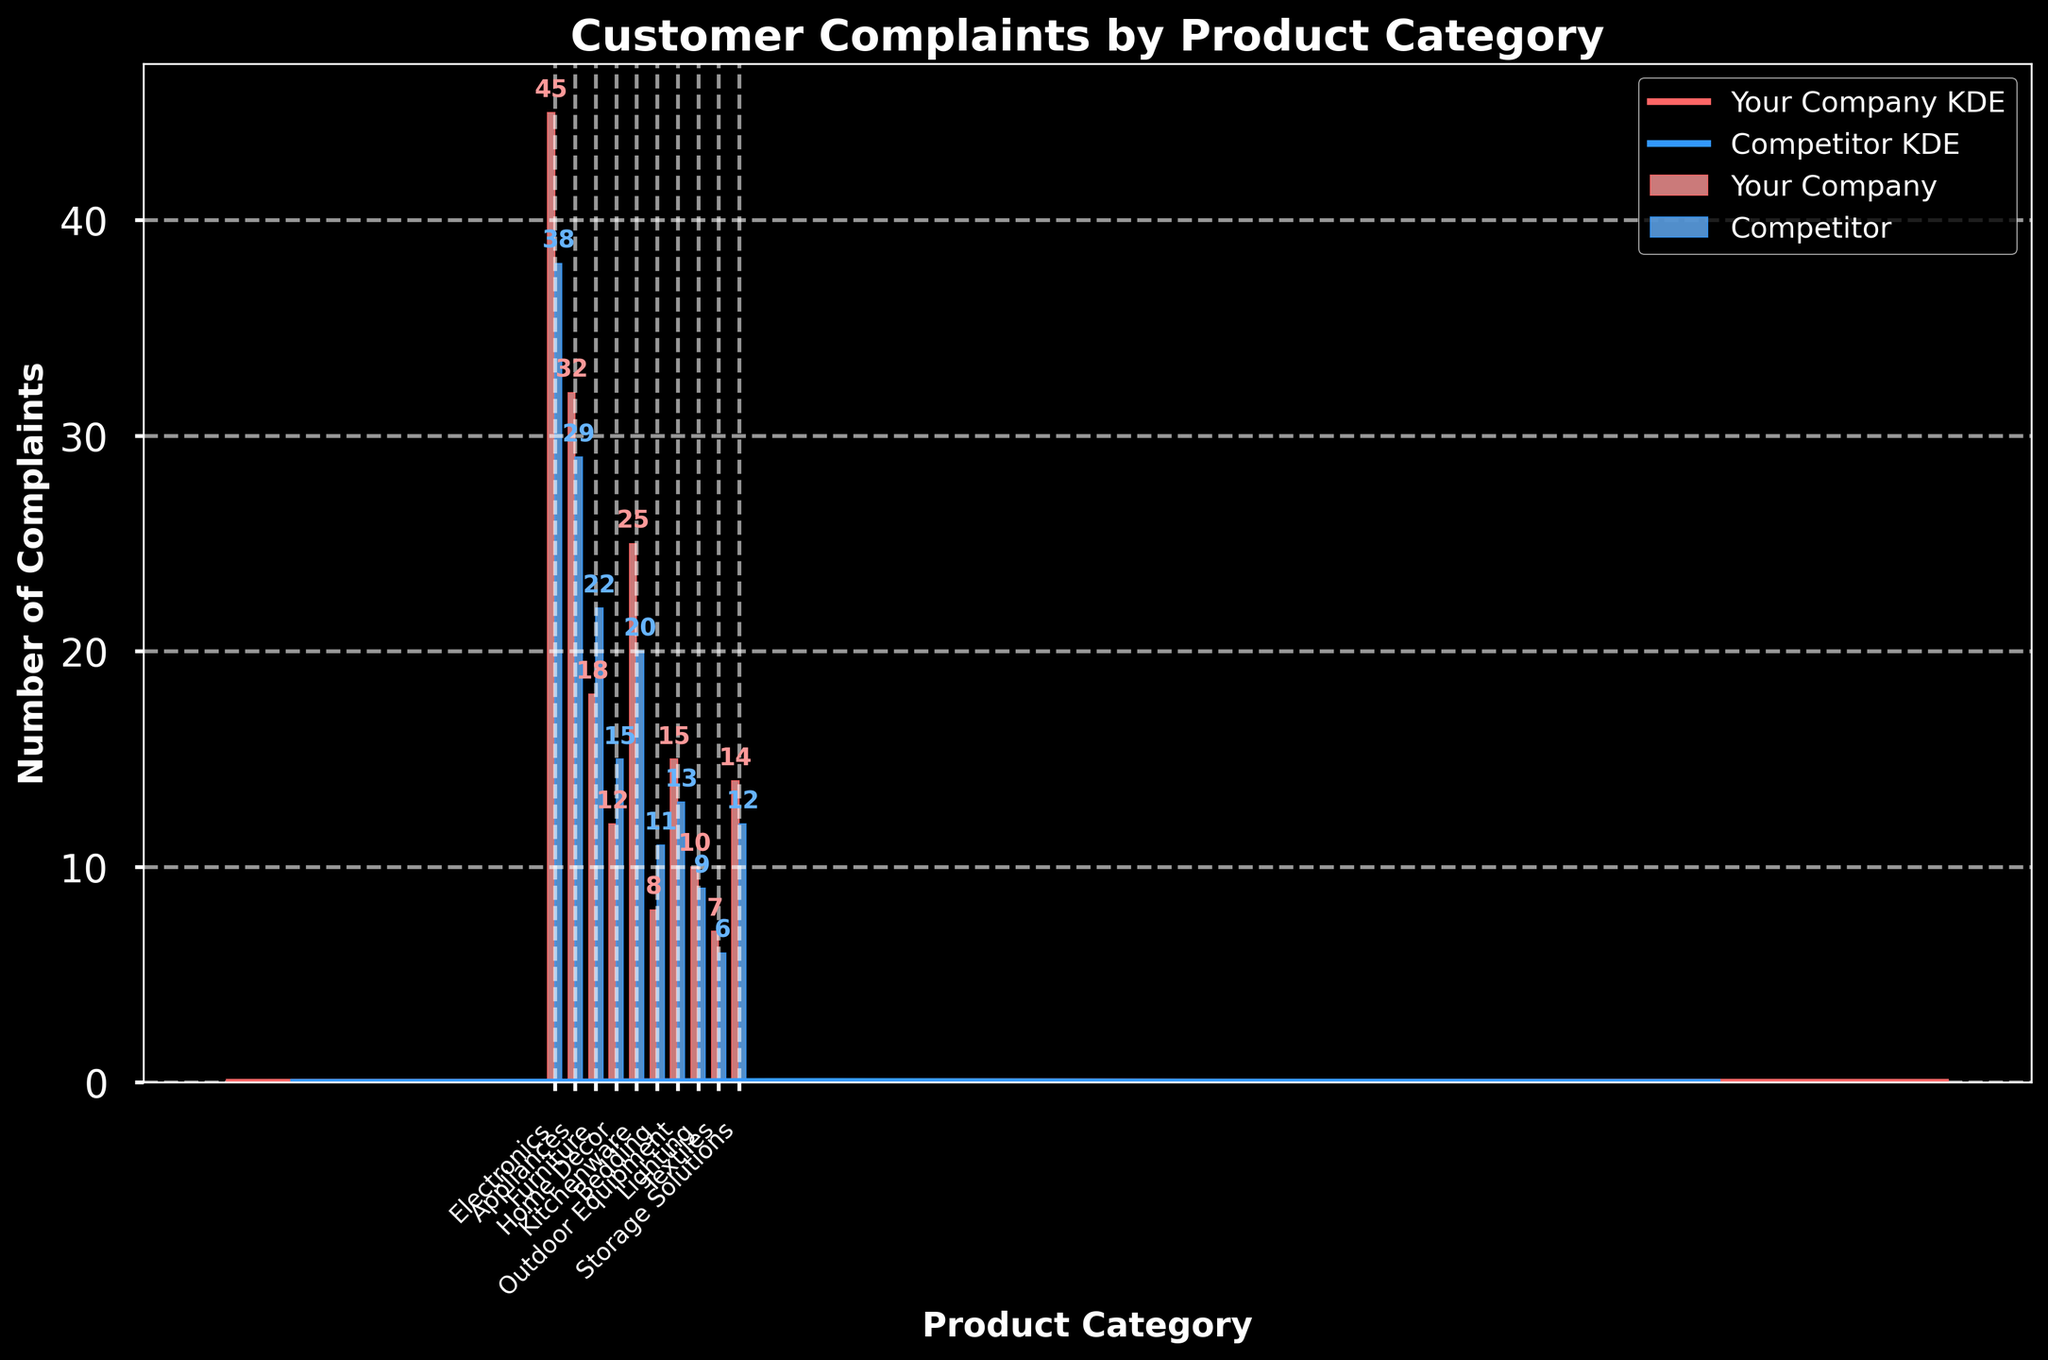What's the title of the figure? Look at the top center of the figure where the title is usually placed. It reads "Customer Complaints by Product Category".
Answer: Customer Complaints by Product Category Which product category has the highest number of complaints for your company? Check the heights of the bars representing your company's complaints. The tallest bar corresponds to "Electronics" with 45 complaints.
Answer: Electronics What's the difference in the number of complaints between your company and the competitor for the 'Furniture' category? Identify the bar heights for 'Furniture' for both companies. Your company has 18 complaints and the competitor has 22. The difference is 22 - 18 = 4.
Answer: 4 How do the complaint patterns for 'Kitchenware' compare between your company and the competitor? Compare the bars for 'Kitchenware'. Your company has 25 complaints and the competitor has 20. The KDE curves for both companies show a higher density around these numbers.
Answer: Your company has more complaints (25 vs 20) Which company has fewer total complaints across all categories? Sum the complaints for each company. Your Company: 45 + 32 + 18 + 12 + 25 + 8 + 15 + 10 + 7 + 14 = 186, Competitor: 38 + 29 + 22 + 15 + 20 + 11 + 13 + 9 + 6 + 12 = 175. The competitor has fewer complaints.
Answer: Competitor What is the average number of complaints for your company across all product categories? Calculate the average using the total complaints for your company. Sum the complaints (186) and divide by the number of categories (10). Average = 186 / 10 = 18.6.
Answer: 18.6 For which product categories does the competitor have more complaints than your company? Compare the bar heights across all categories. The competitor has more complaints in 'Furniture', 'Home Decor', 'Bedding', and 'Lighting'.
Answer: Furniture, Home Decor, Bedding, and Lighting Identify the two categories with the least number of complaints for your company. Look at the bars and select the two shortest ones. These correspond to 'Textiles' and 'Bedding' with 7 and 8 complaints respectively.
Answer: Textiles and Bedding Describe how the KDE (density curve) for your company's complaints changes across different categories. Observe the KDE (density curve) plotted for your company. It shows peaks corresponding to the categories with higher complaints (e.g., Electronics, Kitchenware) and dips for those with fewer complaints (e.g., Textiles, Bedding).
Answer: Peaks around high complaint categories, dips around low complaint categories 